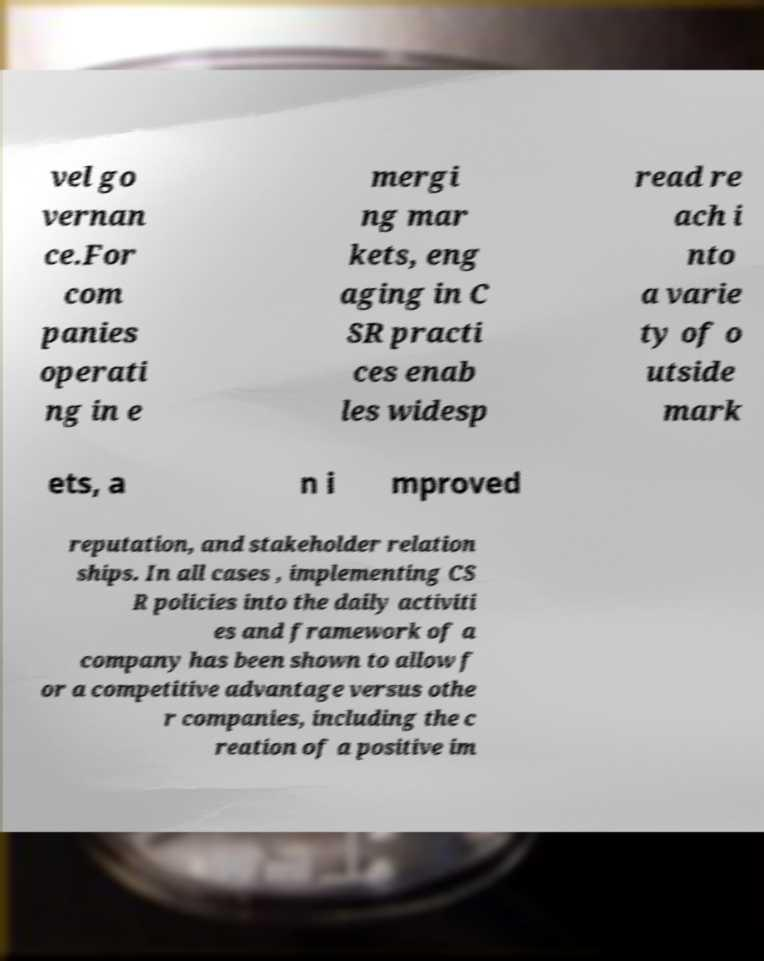Please read and relay the text visible in this image. What does it say? vel go vernan ce.For com panies operati ng in e mergi ng mar kets, eng aging in C SR practi ces enab les widesp read re ach i nto a varie ty of o utside mark ets, a n i mproved reputation, and stakeholder relation ships. In all cases , implementing CS R policies into the daily activiti es and framework of a company has been shown to allow f or a competitive advantage versus othe r companies, including the c reation of a positive im 